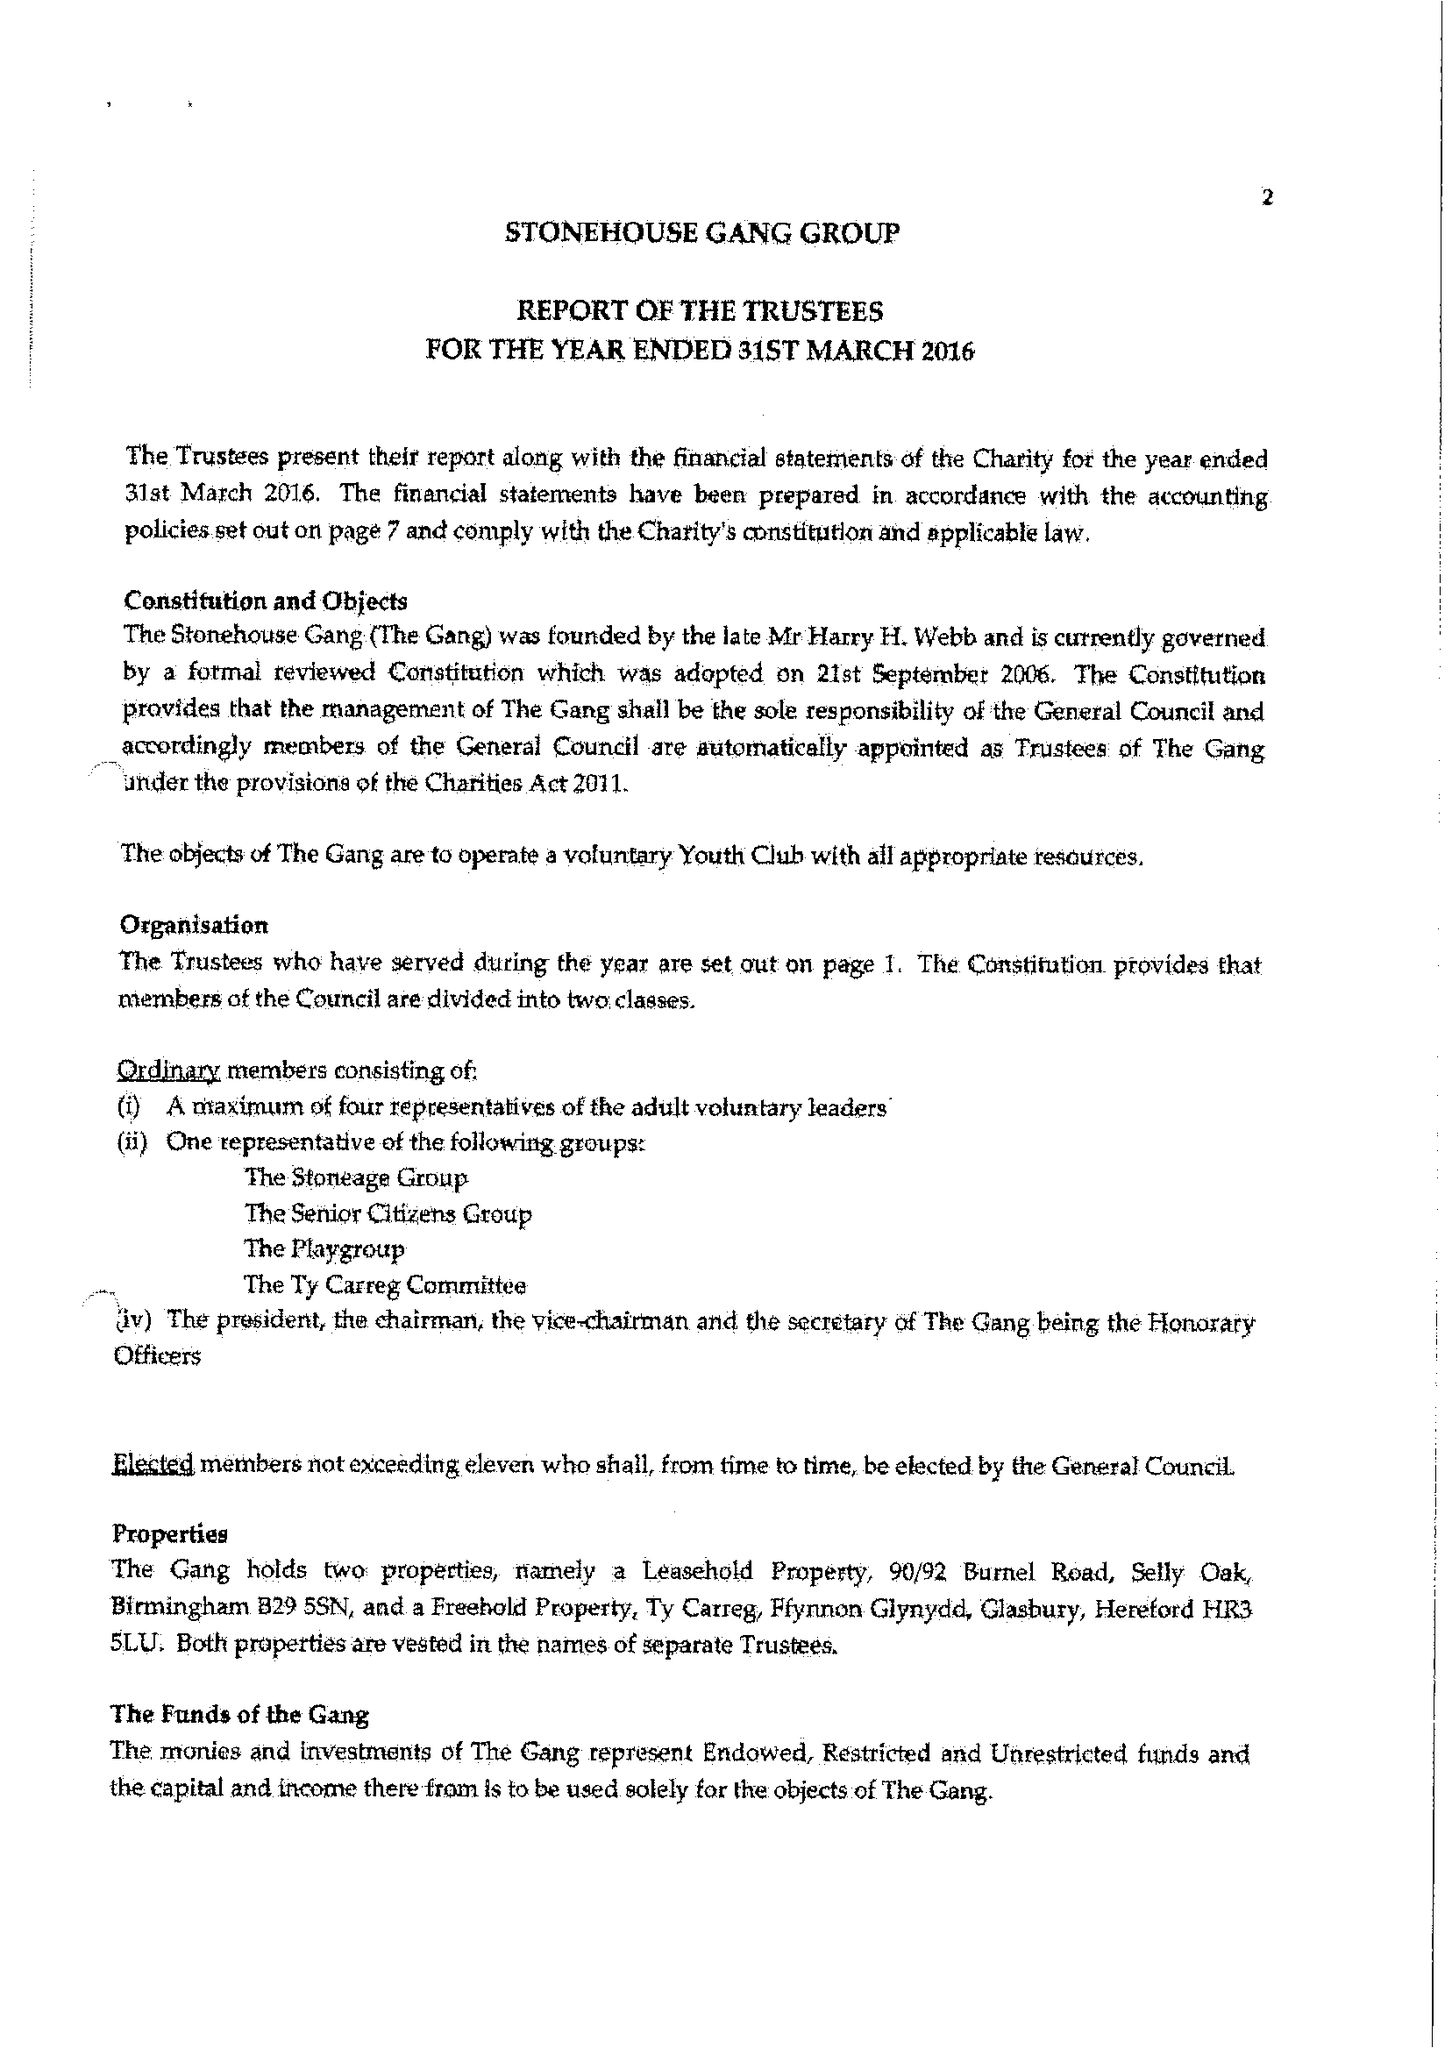What is the value for the income_annually_in_british_pounds?
Answer the question using a single word or phrase. 117902.00 